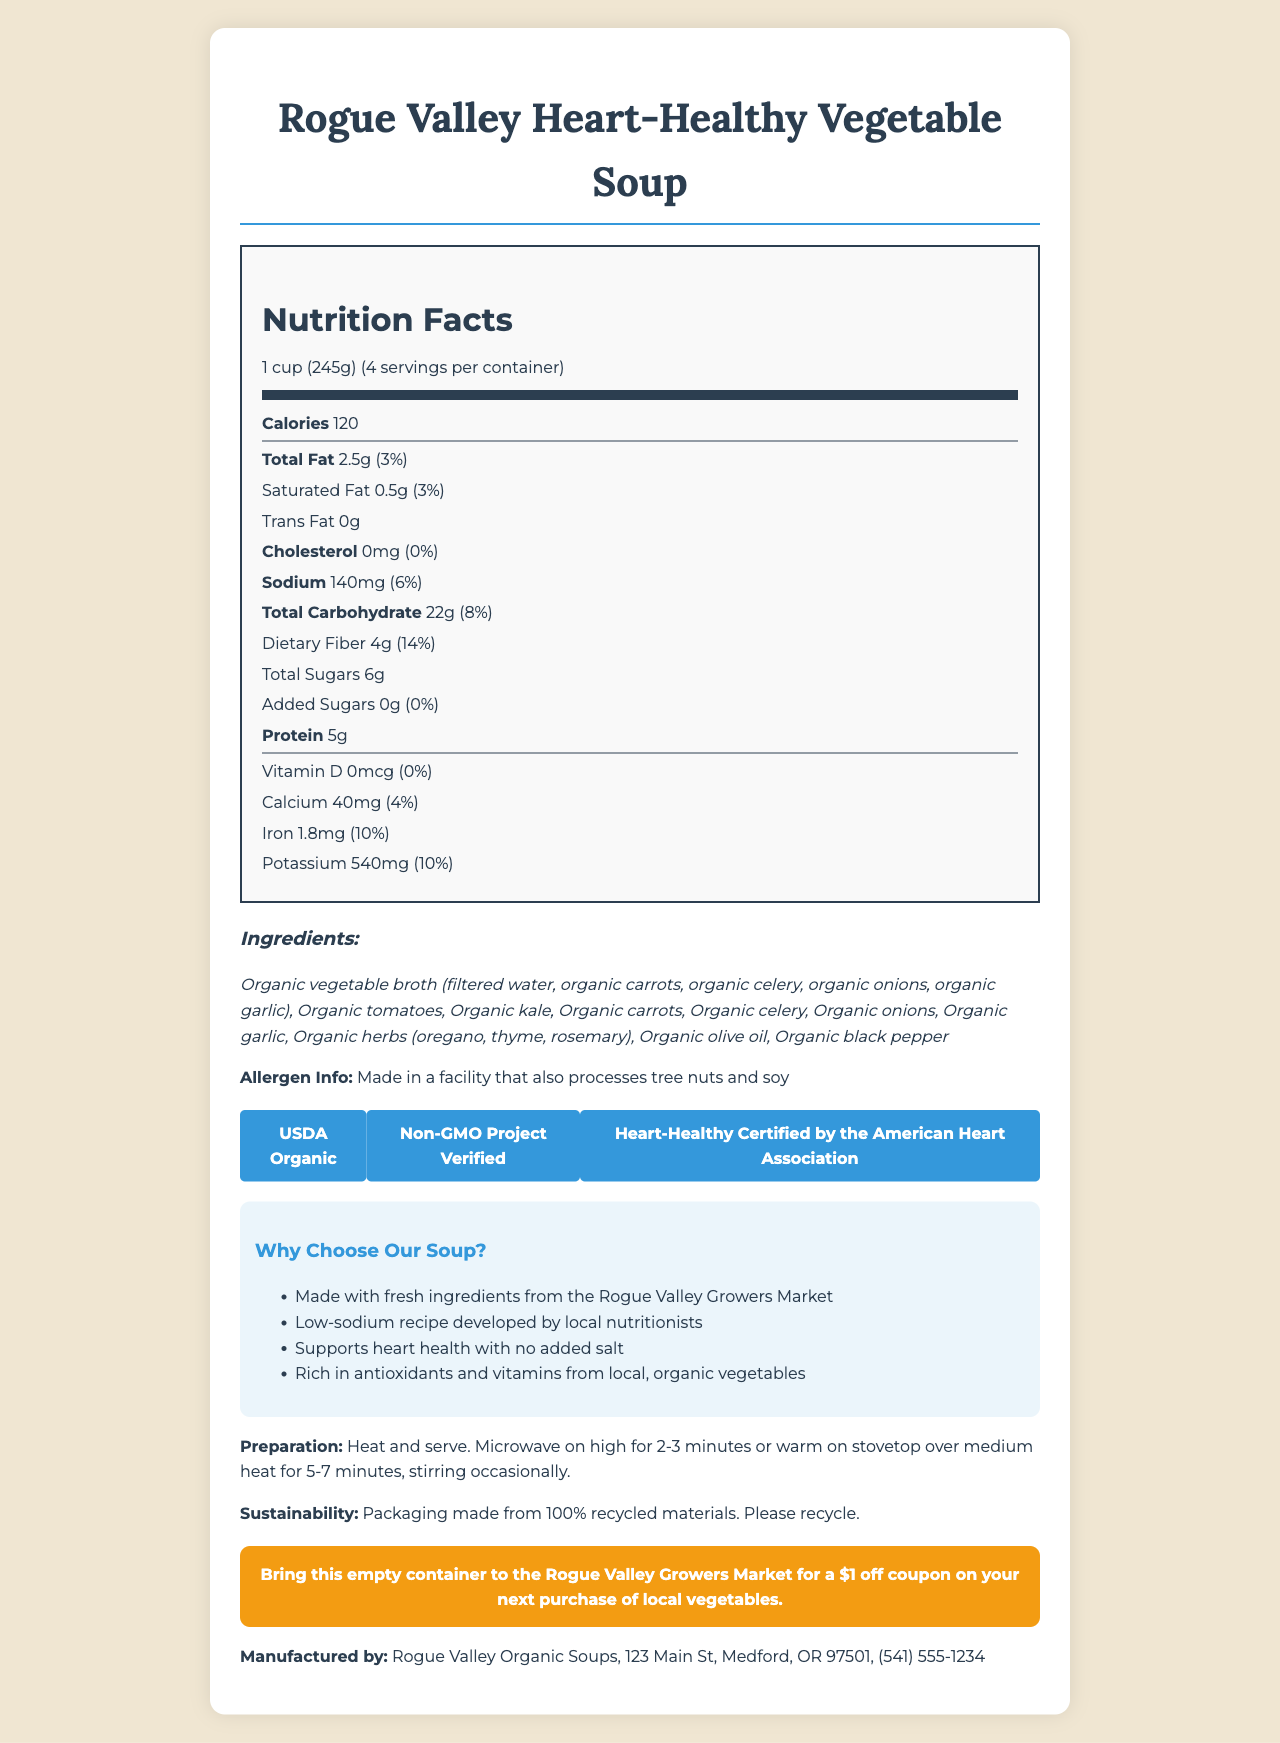what is the serving size for the Rogue Valley Heart-Healthy Vegetable Soup? The serving size is listed in the nutrition facts section as "1 cup (245g)".
Answer: 1 cup (245g) how many servings are there per container? The document states that there are 4 servings per container.
Answer: 4 how many calories are there per serving? According to the nutrition facts section, each serving contains 120 calories.
Answer: 120 which ingredients are included in the vegetable soup? The ingredients are listed in the ingredients section of the document.
Answer: Organic vegetable broth (filtered water, organic carrots, organic celery, organic onions, organic garlic), Organic tomatoes, Organic kale, Organic carrots, Organic celery, Organic onions, Organic garlic, Organic herbs (oregano, thyme, rosemary), Organic olive oil, Organic black pepper what is the sodium content per serving? The sodium content per serving is listed as 140mg.
Answer: 140mg what certifications does the Rogue Valley Heart-Healthy Vegetable Soup have? A. Organic, Non-GMO, Heart-Healthy Certified B. Certified Vegan, Organic C. Gluten-Free, Heart-Healthy Certified The document lists "USDA Organic," "Non-GMO Project Verified," and "Heart-Healthy Certified by the American Heart Association" as certifications.
Answer: A how many grams of saturated fat are there per serving? The saturated fat content per serving is listed as 0.5g.
Answer: 0.5g is there any added sugar in the soup? The document lists "Added Sugars 0g (0%)".
Answer: No what is the address of the manufacturer? The manufacturer information includes the address: 123 Main St, Medford, OR 97501.
Answer: 123 Main St, Medford, OR 97501 how many milligrams of potassium are there per serving? The amount of potassium per serving is listed as 540mg.
Answer: 540mg what daily value percentage of vitamin D does the soup provide? The document states that vitamin D is 0mcg (0%).
Answer: 0% what is the promotional offer associated with this soup? The promotional offer is to bring the empty container to the Rogue Valley Growers Market for a $1 off coupon on the next purchase of local vegetables.
Answer: Bring this empty container to the Rogue Valley Growers Market for a $1 off coupon on your next purchase of local vegetables. does the soup contain trans fat? The nutrition facts state that there is 0g of trans fat per serving.
Answer: No how is the packaging of the product described in terms of sustainability? The sustainability information mentions that the packaging is made from 100% recycled materials and asks to please recycle.
Answer: Packaging made from 100% recycled materials. Please recycle. which of the following statements is not a marketing claim made in the document? I. Made with fresh ingredients from the Rogue Valley Growers Market II. Low-sodium recipe developed by local nutritionists III. Contains high levels of sodium for flavor enhancement IV. Supports heart health with no added salt The document states that the soup supports heart health with no added salt, and it's low-sodium, making option III incorrect.
Answer: III is there any allergen information provided? The document states that the soup is made in a facility that also processes tree nuts and soy.
Answer: Yes what is the main idea of the document? The document comprehensively describes the product, covering various aspects like nutritional content, ingredients, health certifications, and promotional offers, aiming to emphasize its health benefits and sustainability.
Answer: The document provides a detailed nutritional profile, ingredient list, certifications, manufacturer information, preparation instructions, sustainability information, and promotional offer for the Rogue Valley Heart-Healthy Vegetable Soup. It highlights the soup's health benefits, emphasizing it is made with fresh, organic ingredients and supports heart health. what is the annual sales revenue of Rogue Valley Organic Soups? The document does not provide any information about the annual sales revenue of Rogue Valley Organic Soups.
Answer: Not enough information 